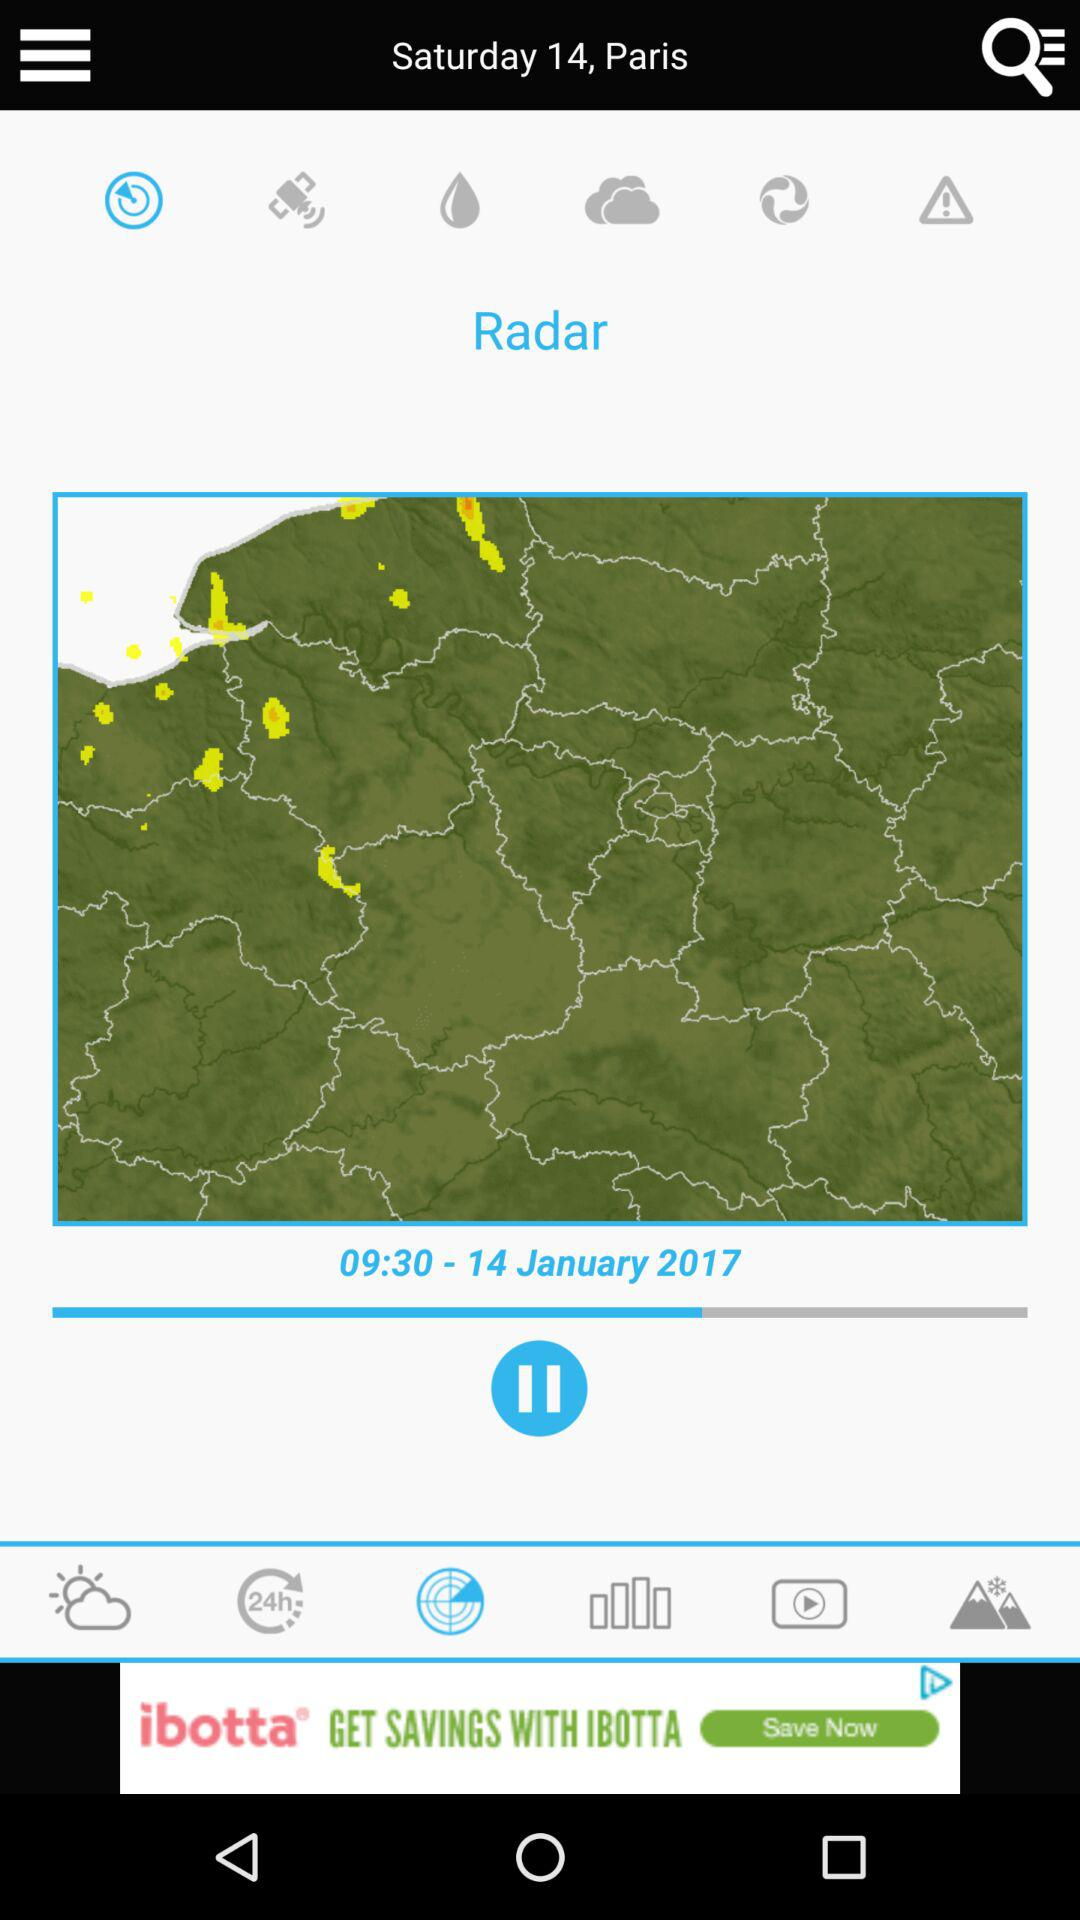What is the time in Paris? The time is 09:30. 